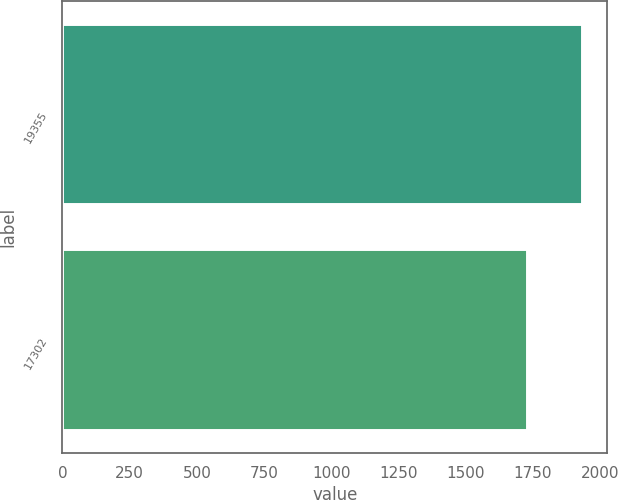Convert chart to OTSL. <chart><loc_0><loc_0><loc_500><loc_500><bar_chart><fcel>19355<fcel>17302<nl><fcel>1930.6<fcel>1726.4<nl></chart> 